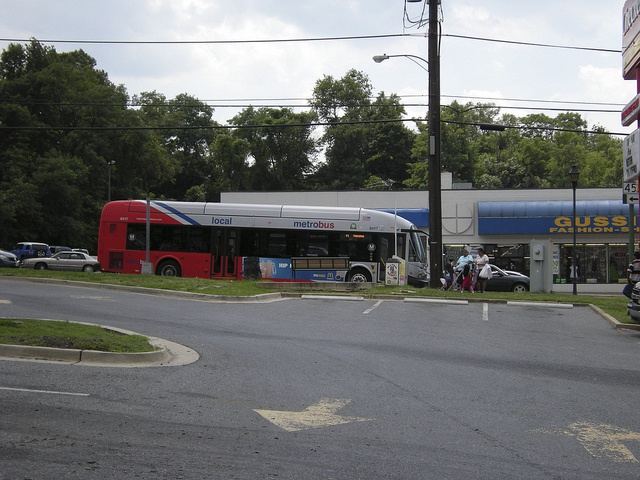Describe the objects in this image and their specific colors. I can see bus in lightgray, black, maroon, darkgray, and gray tones, car in lightgray, black, gray, and darkgray tones, car in lightgray, black, gray, and darkgray tones, bench in lightgray, black, and gray tones, and car in lightgray, black, navy, gray, and darkgray tones in this image. 